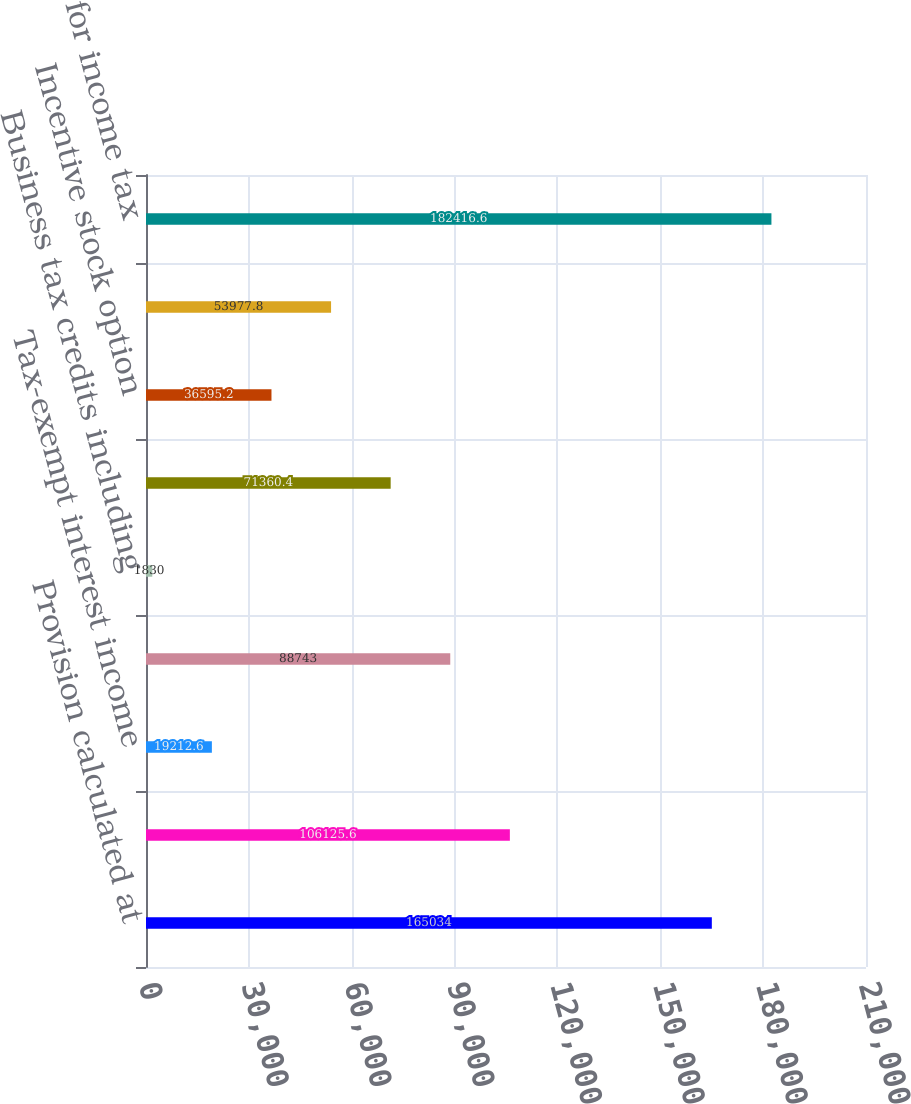<chart> <loc_0><loc_0><loc_500><loc_500><bar_chart><fcel>Provision calculated at<fcel>State income tax net of<fcel>Tax-exempt interest income<fcel>Income on company-owned life<fcel>Business tax credits including<fcel>Business expenses which are<fcel>Incentive stock option<fcel>Other net<fcel>Total provision for income tax<nl><fcel>165034<fcel>106126<fcel>19212.6<fcel>88743<fcel>1830<fcel>71360.4<fcel>36595.2<fcel>53977.8<fcel>182417<nl></chart> 